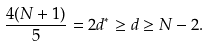<formula> <loc_0><loc_0><loc_500><loc_500>\frac { 4 ( N + 1 ) } { 5 } = 2 d ^ { * } \geq d \geq N - 2 .</formula> 